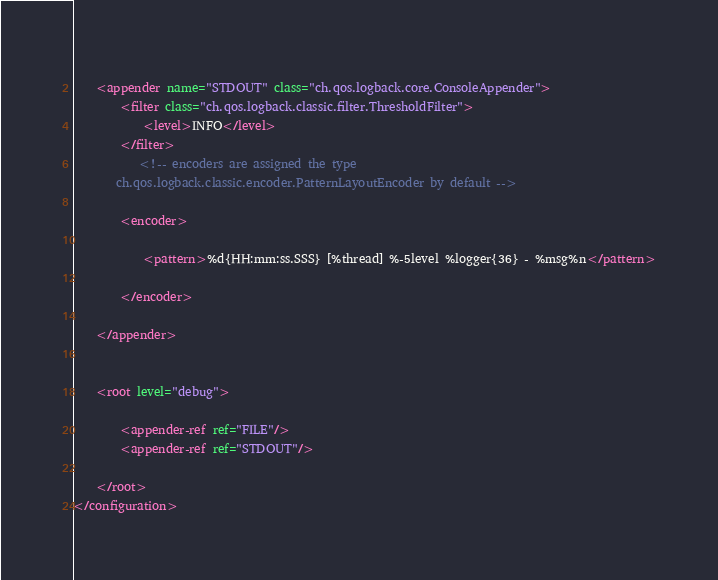<code> <loc_0><loc_0><loc_500><loc_500><_XML_>     
    <appender name="STDOUT" class="ch.qos.logback.core.ConsoleAppender">
        <filter class="ch.qos.logback.classic.filter.ThresholdFilter">
            <level>INFO</level>
        </filter>
            <!-- encoders are assigned the type
         ch.qos.logback.classic.encoder.PatternLayoutEncoder by default -->
           
        <encoder>
                 
            <pattern>%d{HH:mm:ss.SSS} [%thread] %-5level %logger{36} - %msg%n</pattern>
               
        </encoder>
         
    </appender>

     
    <root level="debug">
           
        <appender-ref ref="FILE"/>
        <appender-ref ref="STDOUT"/>
         
    </root>
</configuration></code> 